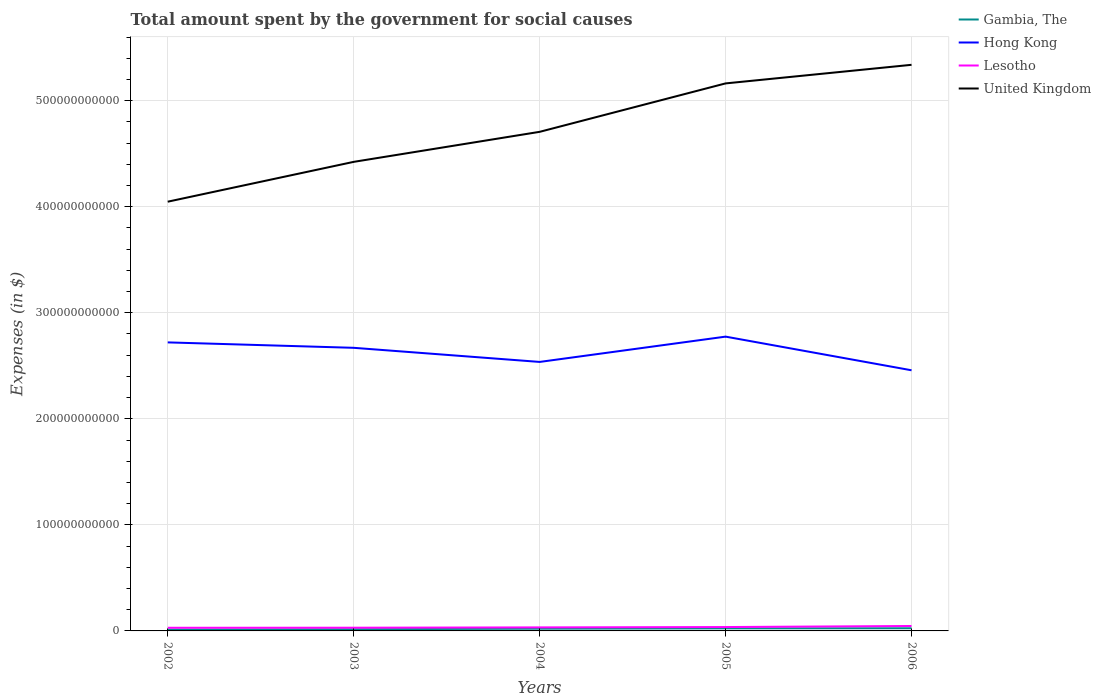Across all years, what is the maximum amount spent for social causes by the government in Hong Kong?
Offer a very short reply. 2.46e+11. What is the total amount spent for social causes by the government in Gambia, The in the graph?
Make the answer very short. -1.24e+09. What is the difference between the highest and the second highest amount spent for social causes by the government in Hong Kong?
Offer a very short reply. 3.17e+1. What is the difference between two consecutive major ticks on the Y-axis?
Give a very brief answer. 1.00e+11. Where does the legend appear in the graph?
Your answer should be compact. Top right. How are the legend labels stacked?
Offer a very short reply. Vertical. What is the title of the graph?
Offer a very short reply. Total amount spent by the government for social causes. What is the label or title of the X-axis?
Make the answer very short. Years. What is the label or title of the Y-axis?
Make the answer very short. Expenses (in $). What is the Expenses (in $) of Gambia, The in 2002?
Your answer should be very brief. 1.28e+09. What is the Expenses (in $) in Hong Kong in 2002?
Provide a succinct answer. 2.72e+11. What is the Expenses (in $) in Lesotho in 2002?
Offer a very short reply. 2.98e+09. What is the Expenses (in $) in United Kingdom in 2002?
Give a very brief answer. 4.05e+11. What is the Expenses (in $) in Gambia, The in 2003?
Your answer should be very brief. 1.62e+09. What is the Expenses (in $) of Hong Kong in 2003?
Provide a short and direct response. 2.67e+11. What is the Expenses (in $) in Lesotho in 2003?
Make the answer very short. 3.04e+09. What is the Expenses (in $) in United Kingdom in 2003?
Provide a succinct answer. 4.42e+11. What is the Expenses (in $) of Gambia, The in 2004?
Your answer should be very brief. 2.09e+09. What is the Expenses (in $) of Hong Kong in 2004?
Ensure brevity in your answer.  2.54e+11. What is the Expenses (in $) of Lesotho in 2004?
Offer a very short reply. 3.33e+09. What is the Expenses (in $) in United Kingdom in 2004?
Offer a terse response. 4.71e+11. What is the Expenses (in $) in Gambia, The in 2005?
Give a very brief answer. 2.42e+09. What is the Expenses (in $) in Hong Kong in 2005?
Offer a terse response. 2.78e+11. What is the Expenses (in $) in Lesotho in 2005?
Your answer should be very brief. 3.65e+09. What is the Expenses (in $) in United Kingdom in 2005?
Give a very brief answer. 5.16e+11. What is the Expenses (in $) of Gambia, The in 2006?
Your answer should be compact. 2.52e+09. What is the Expenses (in $) in Hong Kong in 2006?
Provide a succinct answer. 2.46e+11. What is the Expenses (in $) in Lesotho in 2006?
Keep it short and to the point. 4.65e+09. What is the Expenses (in $) of United Kingdom in 2006?
Offer a terse response. 5.34e+11. Across all years, what is the maximum Expenses (in $) in Gambia, The?
Provide a succinct answer. 2.52e+09. Across all years, what is the maximum Expenses (in $) of Hong Kong?
Keep it short and to the point. 2.78e+11. Across all years, what is the maximum Expenses (in $) in Lesotho?
Make the answer very short. 4.65e+09. Across all years, what is the maximum Expenses (in $) in United Kingdom?
Your answer should be very brief. 5.34e+11. Across all years, what is the minimum Expenses (in $) in Gambia, The?
Make the answer very short. 1.28e+09. Across all years, what is the minimum Expenses (in $) in Hong Kong?
Provide a short and direct response. 2.46e+11. Across all years, what is the minimum Expenses (in $) in Lesotho?
Provide a succinct answer. 2.98e+09. Across all years, what is the minimum Expenses (in $) in United Kingdom?
Provide a succinct answer. 4.05e+11. What is the total Expenses (in $) of Gambia, The in the graph?
Offer a very short reply. 9.93e+09. What is the total Expenses (in $) in Hong Kong in the graph?
Your response must be concise. 1.32e+12. What is the total Expenses (in $) of Lesotho in the graph?
Provide a succinct answer. 1.77e+1. What is the total Expenses (in $) in United Kingdom in the graph?
Provide a succinct answer. 2.37e+12. What is the difference between the Expenses (in $) in Gambia, The in 2002 and that in 2003?
Keep it short and to the point. -3.40e+08. What is the difference between the Expenses (in $) of Hong Kong in 2002 and that in 2003?
Your response must be concise. 5.12e+09. What is the difference between the Expenses (in $) of Lesotho in 2002 and that in 2003?
Your answer should be compact. -5.50e+07. What is the difference between the Expenses (in $) of United Kingdom in 2002 and that in 2003?
Your answer should be compact. -3.76e+1. What is the difference between the Expenses (in $) of Gambia, The in 2002 and that in 2004?
Keep it short and to the point. -8.14e+08. What is the difference between the Expenses (in $) of Hong Kong in 2002 and that in 2004?
Your answer should be very brief. 1.84e+1. What is the difference between the Expenses (in $) of Lesotho in 2002 and that in 2004?
Keep it short and to the point. -3.52e+08. What is the difference between the Expenses (in $) of United Kingdom in 2002 and that in 2004?
Your answer should be very brief. -6.59e+1. What is the difference between the Expenses (in $) of Gambia, The in 2002 and that in 2005?
Your response must be concise. -1.14e+09. What is the difference between the Expenses (in $) of Hong Kong in 2002 and that in 2005?
Offer a terse response. -5.43e+09. What is the difference between the Expenses (in $) in Lesotho in 2002 and that in 2005?
Make the answer very short. -6.68e+08. What is the difference between the Expenses (in $) of United Kingdom in 2002 and that in 2005?
Make the answer very short. -1.12e+11. What is the difference between the Expenses (in $) in Gambia, The in 2002 and that in 2006?
Your answer should be compact. -1.24e+09. What is the difference between the Expenses (in $) in Hong Kong in 2002 and that in 2006?
Provide a short and direct response. 2.63e+1. What is the difference between the Expenses (in $) of Lesotho in 2002 and that in 2006?
Provide a short and direct response. -1.67e+09. What is the difference between the Expenses (in $) in United Kingdom in 2002 and that in 2006?
Offer a terse response. -1.29e+11. What is the difference between the Expenses (in $) of Gambia, The in 2003 and that in 2004?
Provide a short and direct response. -4.74e+08. What is the difference between the Expenses (in $) in Hong Kong in 2003 and that in 2004?
Give a very brief answer. 1.33e+1. What is the difference between the Expenses (in $) of Lesotho in 2003 and that in 2004?
Your response must be concise. -2.97e+08. What is the difference between the Expenses (in $) in United Kingdom in 2003 and that in 2004?
Keep it short and to the point. -2.83e+1. What is the difference between the Expenses (in $) of Gambia, The in 2003 and that in 2005?
Offer a terse response. -8.01e+08. What is the difference between the Expenses (in $) of Hong Kong in 2003 and that in 2005?
Ensure brevity in your answer.  -1.05e+1. What is the difference between the Expenses (in $) in Lesotho in 2003 and that in 2005?
Your answer should be compact. -6.13e+08. What is the difference between the Expenses (in $) of United Kingdom in 2003 and that in 2005?
Your answer should be very brief. -7.40e+1. What is the difference between the Expenses (in $) in Gambia, The in 2003 and that in 2006?
Keep it short and to the point. -8.97e+08. What is the difference between the Expenses (in $) in Hong Kong in 2003 and that in 2006?
Make the answer very short. 2.12e+1. What is the difference between the Expenses (in $) of Lesotho in 2003 and that in 2006?
Your answer should be very brief. -1.62e+09. What is the difference between the Expenses (in $) in United Kingdom in 2003 and that in 2006?
Keep it short and to the point. -9.15e+1. What is the difference between the Expenses (in $) of Gambia, The in 2004 and that in 2005?
Offer a very short reply. -3.27e+08. What is the difference between the Expenses (in $) in Hong Kong in 2004 and that in 2005?
Your response must be concise. -2.39e+1. What is the difference between the Expenses (in $) in Lesotho in 2004 and that in 2005?
Give a very brief answer. -3.16e+08. What is the difference between the Expenses (in $) in United Kingdom in 2004 and that in 2005?
Your answer should be very brief. -4.57e+1. What is the difference between the Expenses (in $) of Gambia, The in 2004 and that in 2006?
Your answer should be compact. -4.23e+08. What is the difference between the Expenses (in $) of Hong Kong in 2004 and that in 2006?
Keep it short and to the point. 7.87e+09. What is the difference between the Expenses (in $) of Lesotho in 2004 and that in 2006?
Your answer should be compact. -1.32e+09. What is the difference between the Expenses (in $) of United Kingdom in 2004 and that in 2006?
Your answer should be very brief. -6.32e+1. What is the difference between the Expenses (in $) in Gambia, The in 2005 and that in 2006?
Ensure brevity in your answer.  -9.60e+07. What is the difference between the Expenses (in $) of Hong Kong in 2005 and that in 2006?
Ensure brevity in your answer.  3.17e+1. What is the difference between the Expenses (in $) of Lesotho in 2005 and that in 2006?
Your answer should be compact. -1.00e+09. What is the difference between the Expenses (in $) in United Kingdom in 2005 and that in 2006?
Provide a succinct answer. -1.75e+1. What is the difference between the Expenses (in $) in Gambia, The in 2002 and the Expenses (in $) in Hong Kong in 2003?
Your answer should be compact. -2.66e+11. What is the difference between the Expenses (in $) in Gambia, The in 2002 and the Expenses (in $) in Lesotho in 2003?
Your answer should be very brief. -1.76e+09. What is the difference between the Expenses (in $) in Gambia, The in 2002 and the Expenses (in $) in United Kingdom in 2003?
Offer a very short reply. -4.41e+11. What is the difference between the Expenses (in $) of Hong Kong in 2002 and the Expenses (in $) of Lesotho in 2003?
Your answer should be compact. 2.69e+11. What is the difference between the Expenses (in $) of Hong Kong in 2002 and the Expenses (in $) of United Kingdom in 2003?
Offer a terse response. -1.70e+11. What is the difference between the Expenses (in $) of Lesotho in 2002 and the Expenses (in $) of United Kingdom in 2003?
Your response must be concise. -4.39e+11. What is the difference between the Expenses (in $) of Gambia, The in 2002 and the Expenses (in $) of Hong Kong in 2004?
Ensure brevity in your answer.  -2.52e+11. What is the difference between the Expenses (in $) in Gambia, The in 2002 and the Expenses (in $) in Lesotho in 2004?
Keep it short and to the point. -2.06e+09. What is the difference between the Expenses (in $) in Gambia, The in 2002 and the Expenses (in $) in United Kingdom in 2004?
Offer a very short reply. -4.69e+11. What is the difference between the Expenses (in $) in Hong Kong in 2002 and the Expenses (in $) in Lesotho in 2004?
Provide a short and direct response. 2.69e+11. What is the difference between the Expenses (in $) of Hong Kong in 2002 and the Expenses (in $) of United Kingdom in 2004?
Your answer should be compact. -1.99e+11. What is the difference between the Expenses (in $) in Lesotho in 2002 and the Expenses (in $) in United Kingdom in 2004?
Give a very brief answer. -4.68e+11. What is the difference between the Expenses (in $) of Gambia, The in 2002 and the Expenses (in $) of Hong Kong in 2005?
Provide a succinct answer. -2.76e+11. What is the difference between the Expenses (in $) of Gambia, The in 2002 and the Expenses (in $) of Lesotho in 2005?
Your answer should be compact. -2.37e+09. What is the difference between the Expenses (in $) in Gambia, The in 2002 and the Expenses (in $) in United Kingdom in 2005?
Ensure brevity in your answer.  -5.15e+11. What is the difference between the Expenses (in $) of Hong Kong in 2002 and the Expenses (in $) of Lesotho in 2005?
Ensure brevity in your answer.  2.68e+11. What is the difference between the Expenses (in $) of Hong Kong in 2002 and the Expenses (in $) of United Kingdom in 2005?
Keep it short and to the point. -2.44e+11. What is the difference between the Expenses (in $) in Lesotho in 2002 and the Expenses (in $) in United Kingdom in 2005?
Give a very brief answer. -5.13e+11. What is the difference between the Expenses (in $) of Gambia, The in 2002 and the Expenses (in $) of Hong Kong in 2006?
Offer a very short reply. -2.45e+11. What is the difference between the Expenses (in $) in Gambia, The in 2002 and the Expenses (in $) in Lesotho in 2006?
Provide a short and direct response. -3.37e+09. What is the difference between the Expenses (in $) in Gambia, The in 2002 and the Expenses (in $) in United Kingdom in 2006?
Give a very brief answer. -5.33e+11. What is the difference between the Expenses (in $) of Hong Kong in 2002 and the Expenses (in $) of Lesotho in 2006?
Provide a short and direct response. 2.67e+11. What is the difference between the Expenses (in $) of Hong Kong in 2002 and the Expenses (in $) of United Kingdom in 2006?
Keep it short and to the point. -2.62e+11. What is the difference between the Expenses (in $) in Lesotho in 2002 and the Expenses (in $) in United Kingdom in 2006?
Your answer should be very brief. -5.31e+11. What is the difference between the Expenses (in $) of Gambia, The in 2003 and the Expenses (in $) of Hong Kong in 2004?
Provide a short and direct response. -2.52e+11. What is the difference between the Expenses (in $) in Gambia, The in 2003 and the Expenses (in $) in Lesotho in 2004?
Your response must be concise. -1.71e+09. What is the difference between the Expenses (in $) of Gambia, The in 2003 and the Expenses (in $) of United Kingdom in 2004?
Offer a terse response. -4.69e+11. What is the difference between the Expenses (in $) in Hong Kong in 2003 and the Expenses (in $) in Lesotho in 2004?
Your answer should be compact. 2.64e+11. What is the difference between the Expenses (in $) of Hong Kong in 2003 and the Expenses (in $) of United Kingdom in 2004?
Your answer should be compact. -2.04e+11. What is the difference between the Expenses (in $) of Lesotho in 2003 and the Expenses (in $) of United Kingdom in 2004?
Your response must be concise. -4.68e+11. What is the difference between the Expenses (in $) of Gambia, The in 2003 and the Expenses (in $) of Hong Kong in 2005?
Give a very brief answer. -2.76e+11. What is the difference between the Expenses (in $) in Gambia, The in 2003 and the Expenses (in $) in Lesotho in 2005?
Your response must be concise. -2.03e+09. What is the difference between the Expenses (in $) in Gambia, The in 2003 and the Expenses (in $) in United Kingdom in 2005?
Keep it short and to the point. -5.15e+11. What is the difference between the Expenses (in $) in Hong Kong in 2003 and the Expenses (in $) in Lesotho in 2005?
Make the answer very short. 2.63e+11. What is the difference between the Expenses (in $) of Hong Kong in 2003 and the Expenses (in $) of United Kingdom in 2005?
Your response must be concise. -2.49e+11. What is the difference between the Expenses (in $) in Lesotho in 2003 and the Expenses (in $) in United Kingdom in 2005?
Your answer should be compact. -5.13e+11. What is the difference between the Expenses (in $) of Gambia, The in 2003 and the Expenses (in $) of Hong Kong in 2006?
Your answer should be very brief. -2.44e+11. What is the difference between the Expenses (in $) of Gambia, The in 2003 and the Expenses (in $) of Lesotho in 2006?
Your response must be concise. -3.03e+09. What is the difference between the Expenses (in $) of Gambia, The in 2003 and the Expenses (in $) of United Kingdom in 2006?
Ensure brevity in your answer.  -5.32e+11. What is the difference between the Expenses (in $) of Hong Kong in 2003 and the Expenses (in $) of Lesotho in 2006?
Make the answer very short. 2.62e+11. What is the difference between the Expenses (in $) of Hong Kong in 2003 and the Expenses (in $) of United Kingdom in 2006?
Your answer should be very brief. -2.67e+11. What is the difference between the Expenses (in $) of Lesotho in 2003 and the Expenses (in $) of United Kingdom in 2006?
Your answer should be very brief. -5.31e+11. What is the difference between the Expenses (in $) of Gambia, The in 2004 and the Expenses (in $) of Hong Kong in 2005?
Offer a terse response. -2.75e+11. What is the difference between the Expenses (in $) of Gambia, The in 2004 and the Expenses (in $) of Lesotho in 2005?
Provide a succinct answer. -1.56e+09. What is the difference between the Expenses (in $) of Gambia, The in 2004 and the Expenses (in $) of United Kingdom in 2005?
Provide a short and direct response. -5.14e+11. What is the difference between the Expenses (in $) in Hong Kong in 2004 and the Expenses (in $) in Lesotho in 2005?
Keep it short and to the point. 2.50e+11. What is the difference between the Expenses (in $) in Hong Kong in 2004 and the Expenses (in $) in United Kingdom in 2005?
Make the answer very short. -2.63e+11. What is the difference between the Expenses (in $) in Lesotho in 2004 and the Expenses (in $) in United Kingdom in 2005?
Your answer should be compact. -5.13e+11. What is the difference between the Expenses (in $) of Gambia, The in 2004 and the Expenses (in $) of Hong Kong in 2006?
Ensure brevity in your answer.  -2.44e+11. What is the difference between the Expenses (in $) of Gambia, The in 2004 and the Expenses (in $) of Lesotho in 2006?
Provide a short and direct response. -2.56e+09. What is the difference between the Expenses (in $) in Gambia, The in 2004 and the Expenses (in $) in United Kingdom in 2006?
Provide a succinct answer. -5.32e+11. What is the difference between the Expenses (in $) in Hong Kong in 2004 and the Expenses (in $) in Lesotho in 2006?
Your answer should be compact. 2.49e+11. What is the difference between the Expenses (in $) in Hong Kong in 2004 and the Expenses (in $) in United Kingdom in 2006?
Ensure brevity in your answer.  -2.80e+11. What is the difference between the Expenses (in $) in Lesotho in 2004 and the Expenses (in $) in United Kingdom in 2006?
Keep it short and to the point. -5.31e+11. What is the difference between the Expenses (in $) of Gambia, The in 2005 and the Expenses (in $) of Hong Kong in 2006?
Your answer should be very brief. -2.43e+11. What is the difference between the Expenses (in $) in Gambia, The in 2005 and the Expenses (in $) in Lesotho in 2006?
Make the answer very short. -2.23e+09. What is the difference between the Expenses (in $) in Gambia, The in 2005 and the Expenses (in $) in United Kingdom in 2006?
Offer a terse response. -5.31e+11. What is the difference between the Expenses (in $) of Hong Kong in 2005 and the Expenses (in $) of Lesotho in 2006?
Ensure brevity in your answer.  2.73e+11. What is the difference between the Expenses (in $) in Hong Kong in 2005 and the Expenses (in $) in United Kingdom in 2006?
Offer a very short reply. -2.56e+11. What is the difference between the Expenses (in $) in Lesotho in 2005 and the Expenses (in $) in United Kingdom in 2006?
Give a very brief answer. -5.30e+11. What is the average Expenses (in $) in Gambia, The per year?
Offer a very short reply. 1.99e+09. What is the average Expenses (in $) in Hong Kong per year?
Provide a succinct answer. 2.63e+11. What is the average Expenses (in $) in Lesotho per year?
Ensure brevity in your answer.  3.53e+09. What is the average Expenses (in $) of United Kingdom per year?
Keep it short and to the point. 4.74e+11. In the year 2002, what is the difference between the Expenses (in $) in Gambia, The and Expenses (in $) in Hong Kong?
Your answer should be very brief. -2.71e+11. In the year 2002, what is the difference between the Expenses (in $) of Gambia, The and Expenses (in $) of Lesotho?
Offer a very short reply. -1.70e+09. In the year 2002, what is the difference between the Expenses (in $) in Gambia, The and Expenses (in $) in United Kingdom?
Your answer should be compact. -4.03e+11. In the year 2002, what is the difference between the Expenses (in $) of Hong Kong and Expenses (in $) of Lesotho?
Offer a terse response. 2.69e+11. In the year 2002, what is the difference between the Expenses (in $) in Hong Kong and Expenses (in $) in United Kingdom?
Give a very brief answer. -1.33e+11. In the year 2002, what is the difference between the Expenses (in $) in Lesotho and Expenses (in $) in United Kingdom?
Provide a succinct answer. -4.02e+11. In the year 2003, what is the difference between the Expenses (in $) of Gambia, The and Expenses (in $) of Hong Kong?
Offer a very short reply. -2.65e+11. In the year 2003, what is the difference between the Expenses (in $) of Gambia, The and Expenses (in $) of Lesotho?
Offer a very short reply. -1.42e+09. In the year 2003, what is the difference between the Expenses (in $) in Gambia, The and Expenses (in $) in United Kingdom?
Give a very brief answer. -4.41e+11. In the year 2003, what is the difference between the Expenses (in $) of Hong Kong and Expenses (in $) of Lesotho?
Ensure brevity in your answer.  2.64e+11. In the year 2003, what is the difference between the Expenses (in $) of Hong Kong and Expenses (in $) of United Kingdom?
Make the answer very short. -1.75e+11. In the year 2003, what is the difference between the Expenses (in $) of Lesotho and Expenses (in $) of United Kingdom?
Your response must be concise. -4.39e+11. In the year 2004, what is the difference between the Expenses (in $) in Gambia, The and Expenses (in $) in Hong Kong?
Provide a succinct answer. -2.52e+11. In the year 2004, what is the difference between the Expenses (in $) of Gambia, The and Expenses (in $) of Lesotho?
Keep it short and to the point. -1.24e+09. In the year 2004, what is the difference between the Expenses (in $) in Gambia, The and Expenses (in $) in United Kingdom?
Ensure brevity in your answer.  -4.69e+11. In the year 2004, what is the difference between the Expenses (in $) of Hong Kong and Expenses (in $) of Lesotho?
Ensure brevity in your answer.  2.50e+11. In the year 2004, what is the difference between the Expenses (in $) in Hong Kong and Expenses (in $) in United Kingdom?
Provide a succinct answer. -2.17e+11. In the year 2004, what is the difference between the Expenses (in $) in Lesotho and Expenses (in $) in United Kingdom?
Make the answer very short. -4.67e+11. In the year 2005, what is the difference between the Expenses (in $) in Gambia, The and Expenses (in $) in Hong Kong?
Your answer should be very brief. -2.75e+11. In the year 2005, what is the difference between the Expenses (in $) of Gambia, The and Expenses (in $) of Lesotho?
Provide a short and direct response. -1.23e+09. In the year 2005, what is the difference between the Expenses (in $) in Gambia, The and Expenses (in $) in United Kingdom?
Your answer should be very brief. -5.14e+11. In the year 2005, what is the difference between the Expenses (in $) in Hong Kong and Expenses (in $) in Lesotho?
Ensure brevity in your answer.  2.74e+11. In the year 2005, what is the difference between the Expenses (in $) in Hong Kong and Expenses (in $) in United Kingdom?
Your answer should be compact. -2.39e+11. In the year 2005, what is the difference between the Expenses (in $) of Lesotho and Expenses (in $) of United Kingdom?
Make the answer very short. -5.13e+11. In the year 2006, what is the difference between the Expenses (in $) in Gambia, The and Expenses (in $) in Hong Kong?
Your answer should be compact. -2.43e+11. In the year 2006, what is the difference between the Expenses (in $) in Gambia, The and Expenses (in $) in Lesotho?
Offer a terse response. -2.14e+09. In the year 2006, what is the difference between the Expenses (in $) of Gambia, The and Expenses (in $) of United Kingdom?
Make the answer very short. -5.31e+11. In the year 2006, what is the difference between the Expenses (in $) in Hong Kong and Expenses (in $) in Lesotho?
Keep it short and to the point. 2.41e+11. In the year 2006, what is the difference between the Expenses (in $) in Hong Kong and Expenses (in $) in United Kingdom?
Offer a terse response. -2.88e+11. In the year 2006, what is the difference between the Expenses (in $) of Lesotho and Expenses (in $) of United Kingdom?
Keep it short and to the point. -5.29e+11. What is the ratio of the Expenses (in $) in Gambia, The in 2002 to that in 2003?
Provide a succinct answer. 0.79. What is the ratio of the Expenses (in $) in Hong Kong in 2002 to that in 2003?
Offer a very short reply. 1.02. What is the ratio of the Expenses (in $) in Lesotho in 2002 to that in 2003?
Provide a succinct answer. 0.98. What is the ratio of the Expenses (in $) in United Kingdom in 2002 to that in 2003?
Provide a succinct answer. 0.92. What is the ratio of the Expenses (in $) of Gambia, The in 2002 to that in 2004?
Give a very brief answer. 0.61. What is the ratio of the Expenses (in $) in Hong Kong in 2002 to that in 2004?
Your answer should be very brief. 1.07. What is the ratio of the Expenses (in $) of Lesotho in 2002 to that in 2004?
Provide a short and direct response. 0.89. What is the ratio of the Expenses (in $) of United Kingdom in 2002 to that in 2004?
Offer a terse response. 0.86. What is the ratio of the Expenses (in $) of Gambia, The in 2002 to that in 2005?
Your response must be concise. 0.53. What is the ratio of the Expenses (in $) in Hong Kong in 2002 to that in 2005?
Give a very brief answer. 0.98. What is the ratio of the Expenses (in $) in Lesotho in 2002 to that in 2005?
Your response must be concise. 0.82. What is the ratio of the Expenses (in $) of United Kingdom in 2002 to that in 2005?
Your response must be concise. 0.78. What is the ratio of the Expenses (in $) in Gambia, The in 2002 to that in 2006?
Give a very brief answer. 0.51. What is the ratio of the Expenses (in $) of Hong Kong in 2002 to that in 2006?
Keep it short and to the point. 1.11. What is the ratio of the Expenses (in $) of Lesotho in 2002 to that in 2006?
Make the answer very short. 0.64. What is the ratio of the Expenses (in $) in United Kingdom in 2002 to that in 2006?
Your response must be concise. 0.76. What is the ratio of the Expenses (in $) of Gambia, The in 2003 to that in 2004?
Your answer should be very brief. 0.77. What is the ratio of the Expenses (in $) of Hong Kong in 2003 to that in 2004?
Give a very brief answer. 1.05. What is the ratio of the Expenses (in $) in Lesotho in 2003 to that in 2004?
Keep it short and to the point. 0.91. What is the ratio of the Expenses (in $) in United Kingdom in 2003 to that in 2004?
Offer a very short reply. 0.94. What is the ratio of the Expenses (in $) of Gambia, The in 2003 to that in 2005?
Your response must be concise. 0.67. What is the ratio of the Expenses (in $) of Hong Kong in 2003 to that in 2005?
Offer a terse response. 0.96. What is the ratio of the Expenses (in $) of Lesotho in 2003 to that in 2005?
Provide a short and direct response. 0.83. What is the ratio of the Expenses (in $) of United Kingdom in 2003 to that in 2005?
Provide a short and direct response. 0.86. What is the ratio of the Expenses (in $) in Gambia, The in 2003 to that in 2006?
Ensure brevity in your answer.  0.64. What is the ratio of the Expenses (in $) in Hong Kong in 2003 to that in 2006?
Offer a very short reply. 1.09. What is the ratio of the Expenses (in $) of Lesotho in 2003 to that in 2006?
Your answer should be compact. 0.65. What is the ratio of the Expenses (in $) of United Kingdom in 2003 to that in 2006?
Your answer should be very brief. 0.83. What is the ratio of the Expenses (in $) of Gambia, The in 2004 to that in 2005?
Provide a succinct answer. 0.86. What is the ratio of the Expenses (in $) in Hong Kong in 2004 to that in 2005?
Give a very brief answer. 0.91. What is the ratio of the Expenses (in $) of Lesotho in 2004 to that in 2005?
Offer a very short reply. 0.91. What is the ratio of the Expenses (in $) of United Kingdom in 2004 to that in 2005?
Your answer should be very brief. 0.91. What is the ratio of the Expenses (in $) of Gambia, The in 2004 to that in 2006?
Your response must be concise. 0.83. What is the ratio of the Expenses (in $) of Hong Kong in 2004 to that in 2006?
Your response must be concise. 1.03. What is the ratio of the Expenses (in $) in Lesotho in 2004 to that in 2006?
Offer a very short reply. 0.72. What is the ratio of the Expenses (in $) in United Kingdom in 2004 to that in 2006?
Give a very brief answer. 0.88. What is the ratio of the Expenses (in $) in Gambia, The in 2005 to that in 2006?
Keep it short and to the point. 0.96. What is the ratio of the Expenses (in $) of Hong Kong in 2005 to that in 2006?
Offer a very short reply. 1.13. What is the ratio of the Expenses (in $) in Lesotho in 2005 to that in 2006?
Provide a short and direct response. 0.78. What is the ratio of the Expenses (in $) of United Kingdom in 2005 to that in 2006?
Give a very brief answer. 0.97. What is the difference between the highest and the second highest Expenses (in $) of Gambia, The?
Offer a terse response. 9.60e+07. What is the difference between the highest and the second highest Expenses (in $) of Hong Kong?
Give a very brief answer. 5.43e+09. What is the difference between the highest and the second highest Expenses (in $) in Lesotho?
Provide a succinct answer. 1.00e+09. What is the difference between the highest and the second highest Expenses (in $) in United Kingdom?
Provide a succinct answer. 1.75e+1. What is the difference between the highest and the lowest Expenses (in $) of Gambia, The?
Provide a short and direct response. 1.24e+09. What is the difference between the highest and the lowest Expenses (in $) of Hong Kong?
Ensure brevity in your answer.  3.17e+1. What is the difference between the highest and the lowest Expenses (in $) in Lesotho?
Keep it short and to the point. 1.67e+09. What is the difference between the highest and the lowest Expenses (in $) of United Kingdom?
Keep it short and to the point. 1.29e+11. 